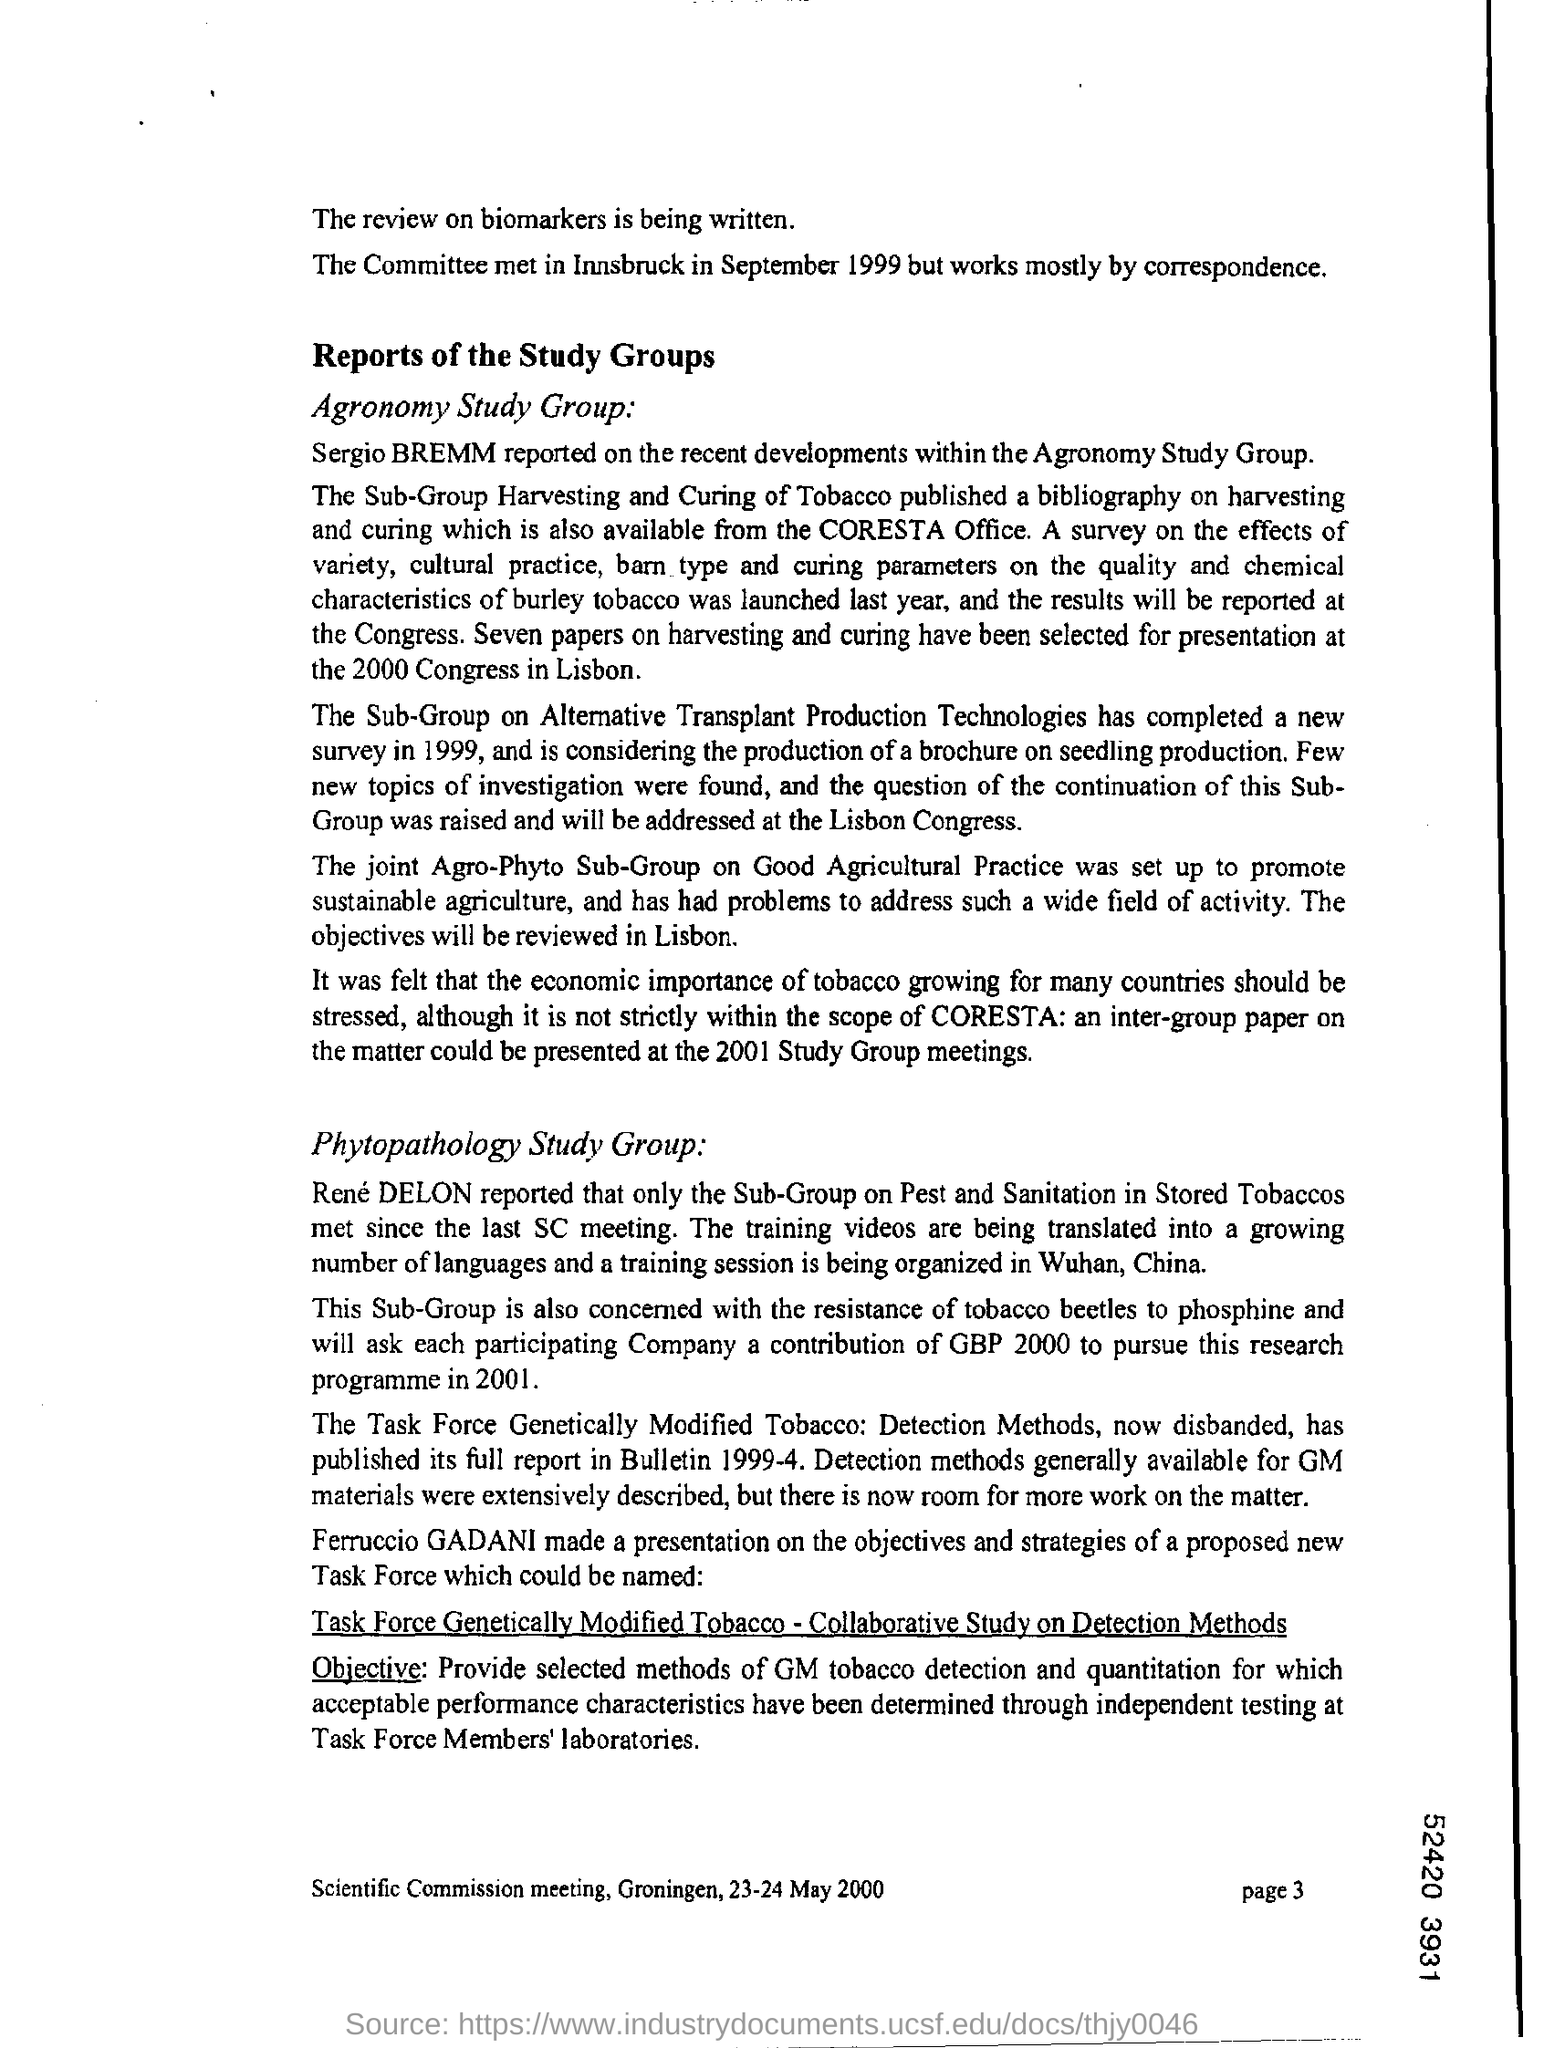Indicate a few pertinent items in this graphic. Mention the page number at the bottom right corner of the page 3... 